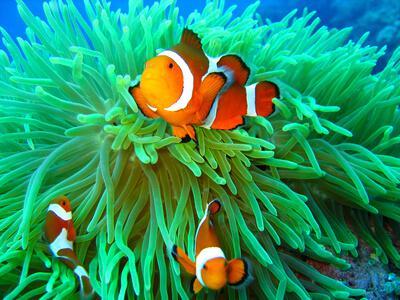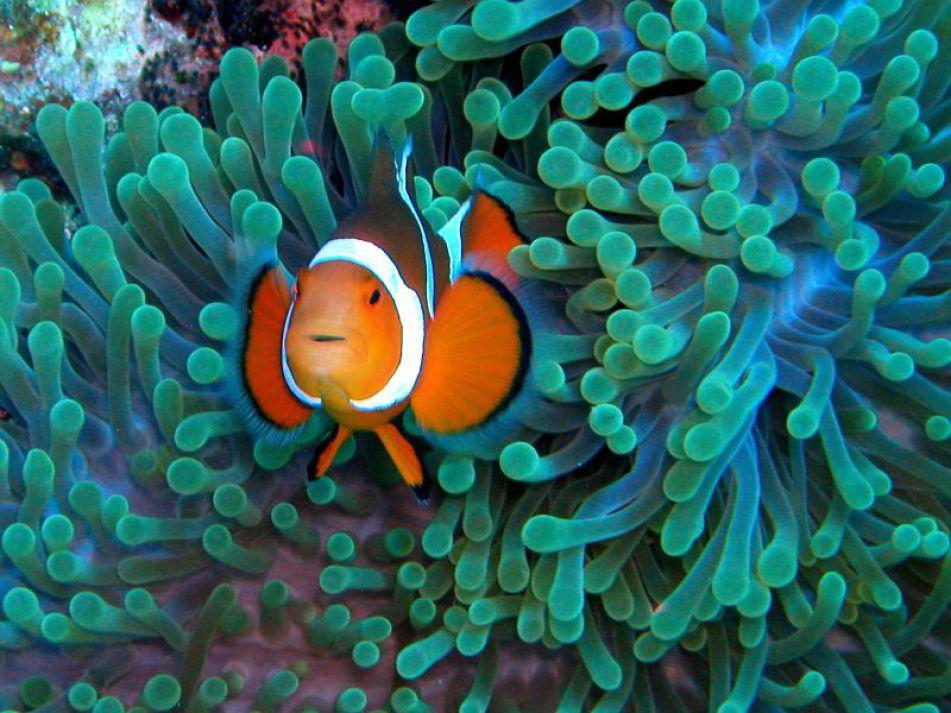The first image is the image on the left, the second image is the image on the right. For the images shown, is this caption "At least three orange and white fish swim in the water." true? Answer yes or no. Yes. The first image is the image on the left, the second image is the image on the right. For the images displayed, is the sentence "There are at most three clownfish swimming." factually correct? Answer yes or no. No. 